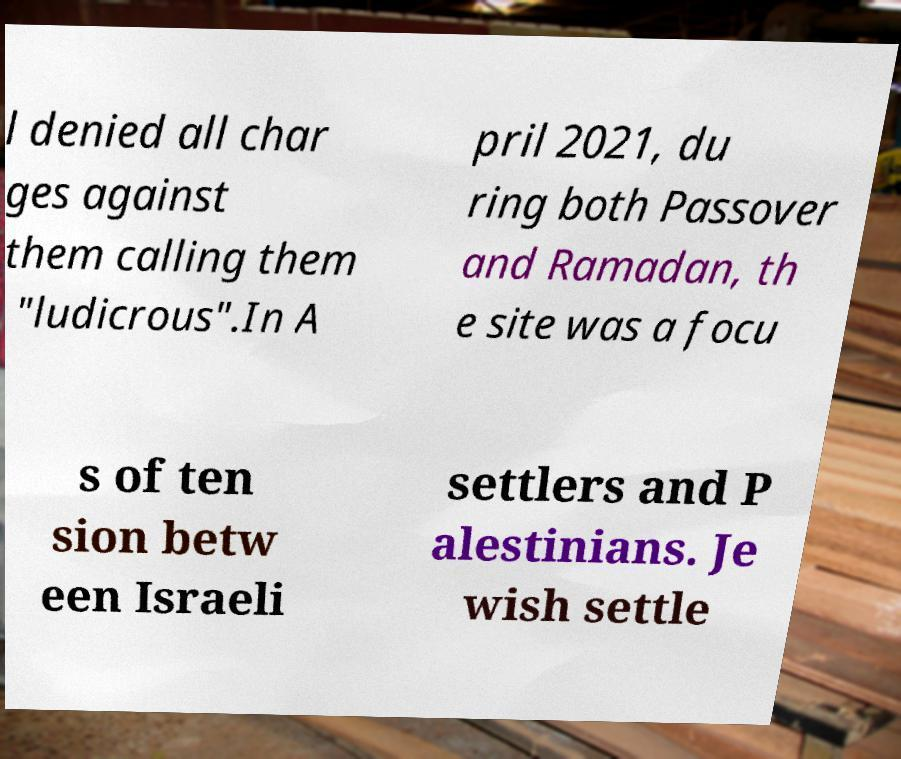Can you accurately transcribe the text from the provided image for me? l denied all char ges against them calling them "ludicrous".In A pril 2021, du ring both Passover and Ramadan, th e site was a focu s of ten sion betw een Israeli settlers and P alestinians. Je wish settle 